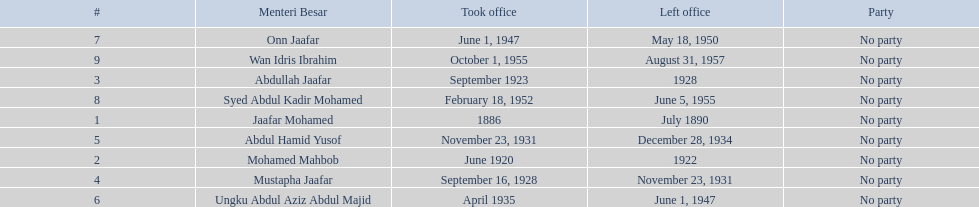Who were all of the menteri besars? Jaafar Mohamed, Mohamed Mahbob, Abdullah Jaafar, Mustapha Jaafar, Abdul Hamid Yusof, Ungku Abdul Aziz Abdul Majid, Onn Jaafar, Syed Abdul Kadir Mohamed, Wan Idris Ibrahim. When did they take office? 1886, June 1920, September 1923, September 16, 1928, November 23, 1931, April 1935, June 1, 1947, February 18, 1952, October 1, 1955. And when did they leave? July 1890, 1922, 1928, November 23, 1931, December 28, 1934, June 1, 1947, May 18, 1950, June 5, 1955, August 31, 1957. Now, who was in office for less than four years? Mohamed Mahbob. 